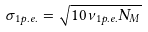<formula> <loc_0><loc_0><loc_500><loc_500>\sigma _ { 1 p . e . } = { \sqrt { 1 0 \nu _ { 1 p . e . } N _ { M } } }</formula> 